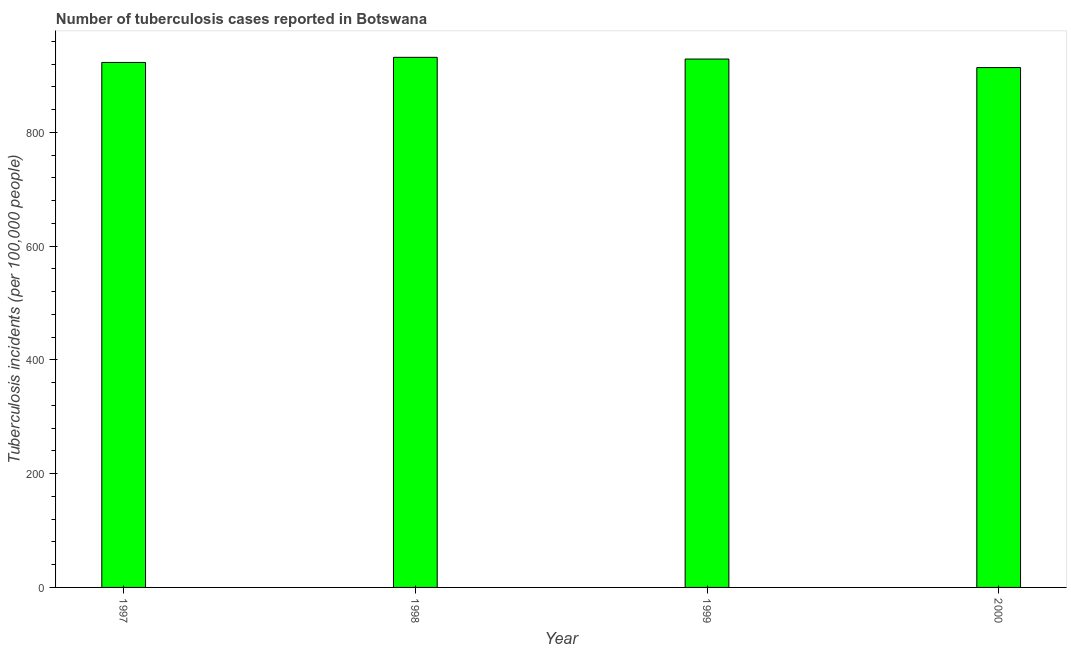Does the graph contain any zero values?
Provide a succinct answer. No. Does the graph contain grids?
Offer a very short reply. No. What is the title of the graph?
Ensure brevity in your answer.  Number of tuberculosis cases reported in Botswana. What is the label or title of the Y-axis?
Ensure brevity in your answer.  Tuberculosis incidents (per 100,0 people). What is the number of tuberculosis incidents in 1998?
Keep it short and to the point. 932. Across all years, what is the maximum number of tuberculosis incidents?
Give a very brief answer. 932. Across all years, what is the minimum number of tuberculosis incidents?
Provide a short and direct response. 914. In which year was the number of tuberculosis incidents maximum?
Give a very brief answer. 1998. In which year was the number of tuberculosis incidents minimum?
Make the answer very short. 2000. What is the sum of the number of tuberculosis incidents?
Make the answer very short. 3698. What is the average number of tuberculosis incidents per year?
Ensure brevity in your answer.  924. What is the median number of tuberculosis incidents?
Keep it short and to the point. 926. In how many years, is the number of tuberculosis incidents greater than 440 ?
Offer a very short reply. 4. What is the ratio of the number of tuberculosis incidents in 1998 to that in 2000?
Your response must be concise. 1.02. Is the number of tuberculosis incidents in 1997 less than that in 2000?
Keep it short and to the point. No. What is the difference between the highest and the second highest number of tuberculosis incidents?
Ensure brevity in your answer.  3. In how many years, is the number of tuberculosis incidents greater than the average number of tuberculosis incidents taken over all years?
Provide a short and direct response. 2. How many bars are there?
Keep it short and to the point. 4. Are all the bars in the graph horizontal?
Keep it short and to the point. No. How many years are there in the graph?
Ensure brevity in your answer.  4. Are the values on the major ticks of Y-axis written in scientific E-notation?
Keep it short and to the point. No. What is the Tuberculosis incidents (per 100,000 people) of 1997?
Provide a succinct answer. 923. What is the Tuberculosis incidents (per 100,000 people) in 1998?
Your answer should be very brief. 932. What is the Tuberculosis incidents (per 100,000 people) in 1999?
Offer a very short reply. 929. What is the Tuberculosis incidents (per 100,000 people) of 2000?
Your answer should be compact. 914. What is the difference between the Tuberculosis incidents (per 100,000 people) in 1997 and 1998?
Provide a succinct answer. -9. What is the difference between the Tuberculosis incidents (per 100,000 people) in 1997 and 1999?
Your response must be concise. -6. What is the ratio of the Tuberculosis incidents (per 100,000 people) in 1997 to that in 1998?
Give a very brief answer. 0.99. What is the ratio of the Tuberculosis incidents (per 100,000 people) in 1997 to that in 1999?
Make the answer very short. 0.99. What is the ratio of the Tuberculosis incidents (per 100,000 people) in 1998 to that in 1999?
Give a very brief answer. 1. What is the ratio of the Tuberculosis incidents (per 100,000 people) in 1998 to that in 2000?
Your response must be concise. 1.02. 